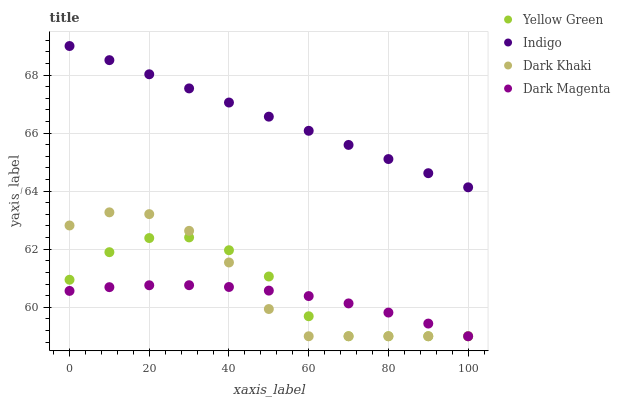Does Dark Magenta have the minimum area under the curve?
Answer yes or no. Yes. Does Indigo have the maximum area under the curve?
Answer yes or no. Yes. Does Yellow Green have the minimum area under the curve?
Answer yes or no. No. Does Yellow Green have the maximum area under the curve?
Answer yes or no. No. Is Indigo the smoothest?
Answer yes or no. Yes. Is Yellow Green the roughest?
Answer yes or no. Yes. Is Yellow Green the smoothest?
Answer yes or no. No. Is Indigo the roughest?
Answer yes or no. No. Does Dark Khaki have the lowest value?
Answer yes or no. Yes. Does Indigo have the lowest value?
Answer yes or no. No. Does Indigo have the highest value?
Answer yes or no. Yes. Does Yellow Green have the highest value?
Answer yes or no. No. Is Dark Khaki less than Indigo?
Answer yes or no. Yes. Is Indigo greater than Dark Khaki?
Answer yes or no. Yes. Does Yellow Green intersect Dark Khaki?
Answer yes or no. Yes. Is Yellow Green less than Dark Khaki?
Answer yes or no. No. Is Yellow Green greater than Dark Khaki?
Answer yes or no. No. Does Dark Khaki intersect Indigo?
Answer yes or no. No. 